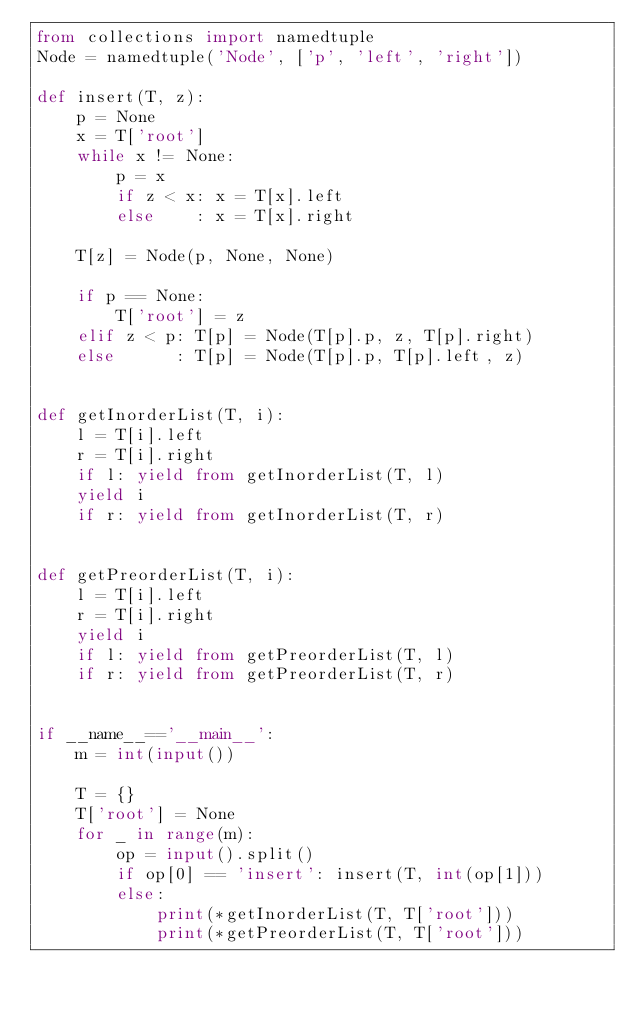Convert code to text. <code><loc_0><loc_0><loc_500><loc_500><_Python_>from collections import namedtuple
Node = namedtuple('Node', ['p', 'left', 'right'])

def insert(T, z):
    p = None
    x = T['root']
    while x != None:
        p = x
        if z < x: x = T[x].left
        else    : x = T[x].right

    T[z] = Node(p, None, None)

    if p == None:
        T['root'] = z
    elif z < p: T[p] = Node(T[p].p, z, T[p].right)
    else      : T[p] = Node(T[p].p, T[p].left, z)

 
def getInorderList(T, i):
    l = T[i].left
    r = T[i].right
    if l: yield from getInorderList(T, l)
    yield i
    if r: yield from getInorderList(T, r)


def getPreorderList(T, i):
    l = T[i].left
    r = T[i].right
    yield i
    if l: yield from getPreorderList(T, l)
    if r: yield from getPreorderList(T, r)


if __name__=='__main__':
    m = int(input())

    T = {}
    T['root'] = None
    for _ in range(m):        
        op = input().split()
        if op[0] == 'insert': insert(T, int(op[1]))
        else:
            print(*getInorderList(T, T['root']))
            print(*getPreorderList(T, T['root']))</code> 